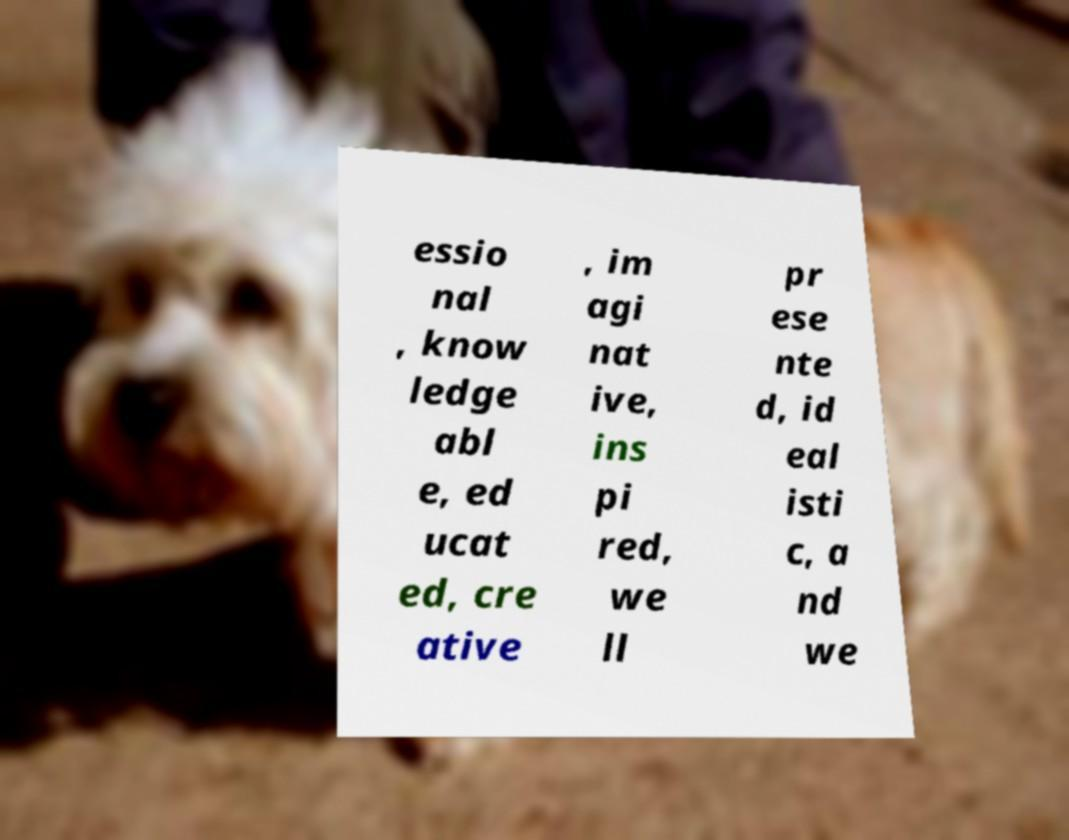Can you read and provide the text displayed in the image?This photo seems to have some interesting text. Can you extract and type it out for me? essio nal , know ledge abl e, ed ucat ed, cre ative , im agi nat ive, ins pi red, we ll pr ese nte d, id eal isti c, a nd we 